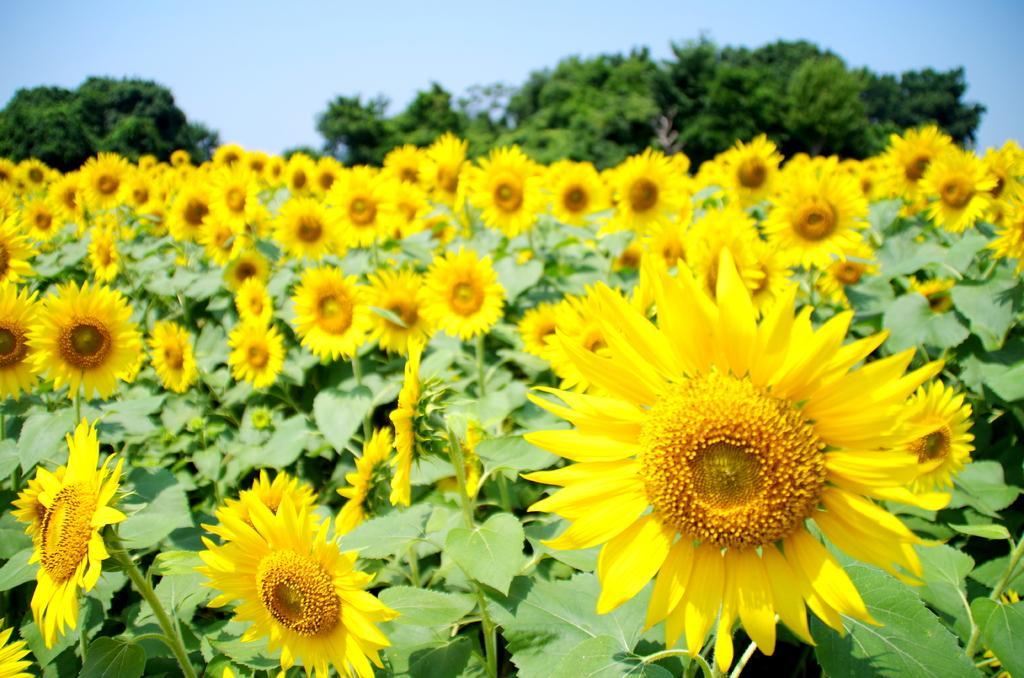What type of vegetation can be seen in the image? There are plants and flowers in the image. What else can be seen in the background of the image? There are trees visible in the background of the image. What is visible at the top of the image? The sky is visible at the top of the image. What type of transport is used by the scarecrow in the image? There is no scarecrow present in the image, so it is not possible to determine what type of transport it might use. 